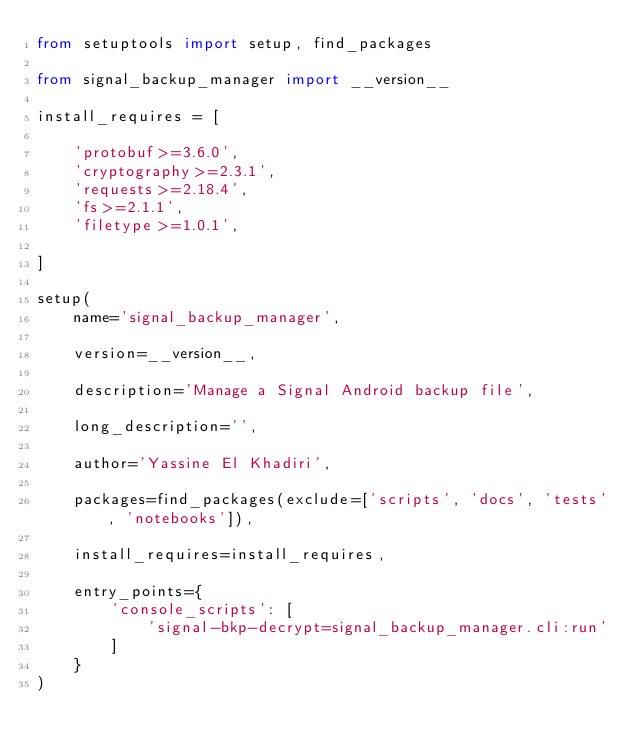Convert code to text. <code><loc_0><loc_0><loc_500><loc_500><_Python_>from setuptools import setup, find_packages

from signal_backup_manager import __version__

install_requires = [

    'protobuf>=3.6.0',
    'cryptography>=2.3.1',
    'requests>=2.18.4',
    'fs>=2.1.1',
    'filetype>=1.0.1',

]

setup(
    name='signal_backup_manager',

    version=__version__,

    description='Manage a Signal Android backup file',

    long_description='',

    author='Yassine El Khadiri',

    packages=find_packages(exclude=['scripts', 'docs', 'tests', 'notebooks']),

    install_requires=install_requires,

    entry_points={
        'console_scripts': [
            'signal-bkp-decrypt=signal_backup_manager.cli:run'
        ]
    }
)
</code> 